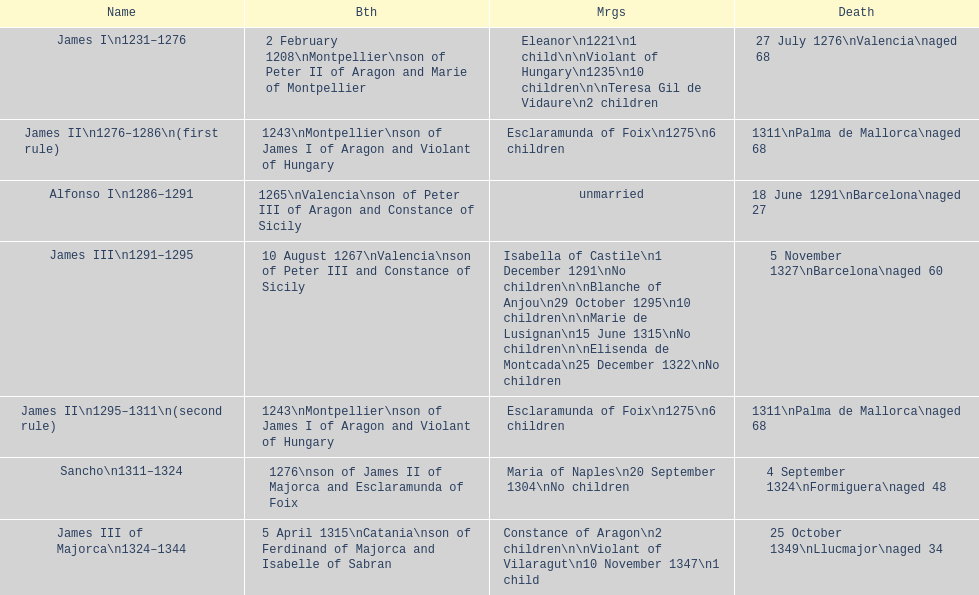Who ascended to power following the reign of james iii? James II. Could you parse the entire table? {'header': ['Name', 'Bth', 'Mrgs', 'Death'], 'rows': [['James I\\n1231–1276', '2 February 1208\\nMontpellier\\nson of Peter II of Aragon and Marie of Montpellier', 'Eleanor\\n1221\\n1 child\\n\\nViolant of Hungary\\n1235\\n10 children\\n\\nTeresa Gil de Vidaure\\n2 children', '27 July 1276\\nValencia\\naged 68'], ['James II\\n1276–1286\\n(first rule)', '1243\\nMontpellier\\nson of James I of Aragon and Violant of Hungary', 'Esclaramunda of Foix\\n1275\\n6 children', '1311\\nPalma de Mallorca\\naged 68'], ['Alfonso I\\n1286–1291', '1265\\nValencia\\nson of Peter III of Aragon and Constance of Sicily', 'unmarried', '18 June 1291\\nBarcelona\\naged 27'], ['James III\\n1291–1295', '10 August 1267\\nValencia\\nson of Peter III and Constance of Sicily', 'Isabella of Castile\\n1 December 1291\\nNo children\\n\\nBlanche of Anjou\\n29 October 1295\\n10 children\\n\\nMarie de Lusignan\\n15 June 1315\\nNo children\\n\\nElisenda de Montcada\\n25 December 1322\\nNo children', '5 November 1327\\nBarcelona\\naged 60'], ['James II\\n1295–1311\\n(second rule)', '1243\\nMontpellier\\nson of James I of Aragon and Violant of Hungary', 'Esclaramunda of Foix\\n1275\\n6 children', '1311\\nPalma de Mallorca\\naged 68'], ['Sancho\\n1311–1324', '1276\\nson of James II of Majorca and Esclaramunda of Foix', 'Maria of Naples\\n20 September 1304\\nNo children', '4 September 1324\\nFormiguera\\naged 48'], ['James III of Majorca\\n1324–1344', '5 April 1315\\nCatania\\nson of Ferdinand of Majorca and Isabelle of Sabran', 'Constance of Aragon\\n2 children\\n\\nViolant of Vilaragut\\n10 November 1347\\n1 child', '25 October 1349\\nLlucmajor\\naged 34']]} 